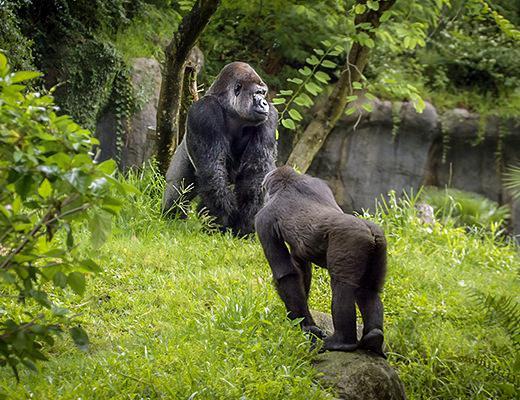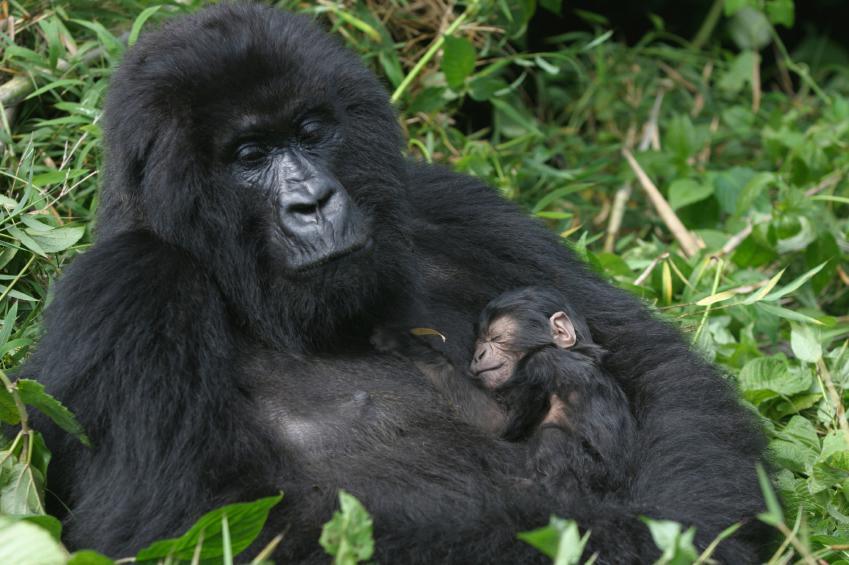The first image is the image on the left, the second image is the image on the right. Assess this claim about the two images: "The right image contains no more than two gorillas.". Correct or not? Answer yes or no. Yes. The first image is the image on the left, the second image is the image on the right. For the images displayed, is the sentence "An image shows exactly one gorilla, which is posed with its chest facing the camera." factually correct? Answer yes or no. No. 